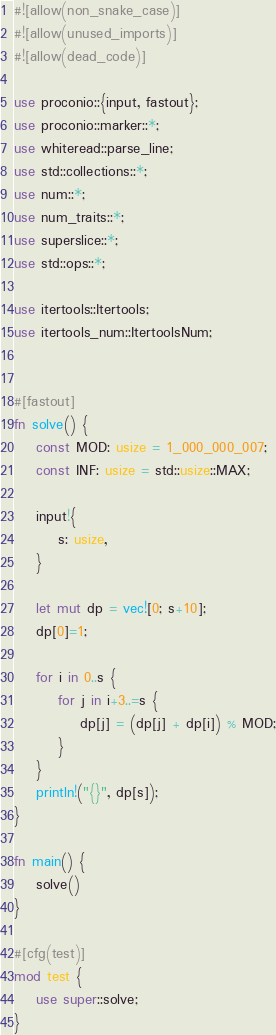Convert code to text. <code><loc_0><loc_0><loc_500><loc_500><_Rust_>#![allow(non_snake_case)]
#![allow(unused_imports)]
#![allow(dead_code)]

use proconio::{input, fastout};
use proconio::marker::*;
use whiteread::parse_line;
use std::collections::*;
use num::*;
use num_traits::*;
use superslice::*;
use std::ops::*;

use itertools::Itertools;
use itertools_num::ItertoolsNum;


#[fastout]
fn solve() {
    const MOD: usize = 1_000_000_007;
    const INF: usize = std::usize::MAX;
    
    input!{
        s: usize,
    }

    let mut dp = vec![0; s+10];
    dp[0]=1;

    for i in 0..s {
        for j in i+3..=s {
            dp[j] = (dp[j] + dp[i]) % MOD;
        }
    }
    println!("{}", dp[s]);
}

fn main() {
    solve()
}

#[cfg(test)]
mod test {
    use super::solve;
}
</code> 